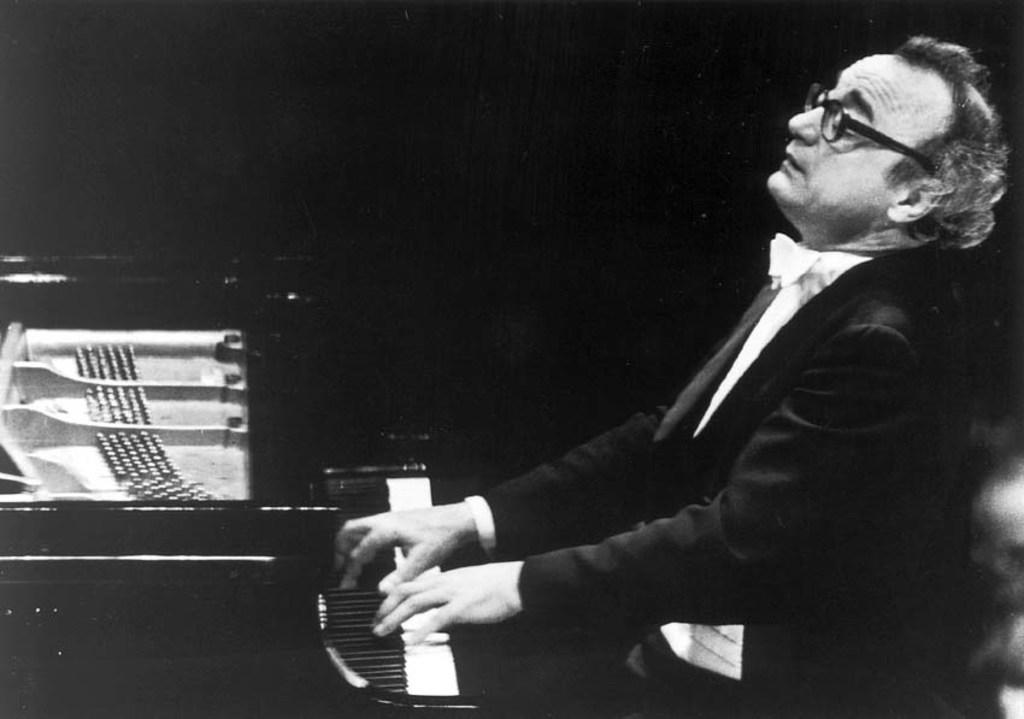What is the main subject of the image? The main subject of the image is a man. What is the man wearing in the image? The man is wearing a black suit in the image. What is the man doing in the image? The man is playing a musical instrument in the image. How many rabbits can be seen playing baseball in the image? There are no rabbits or baseball activity present in the image. What type of destruction is visible in the image? There is no destruction present in the image; it features a man playing a musical instrument while wearing a black suit. 